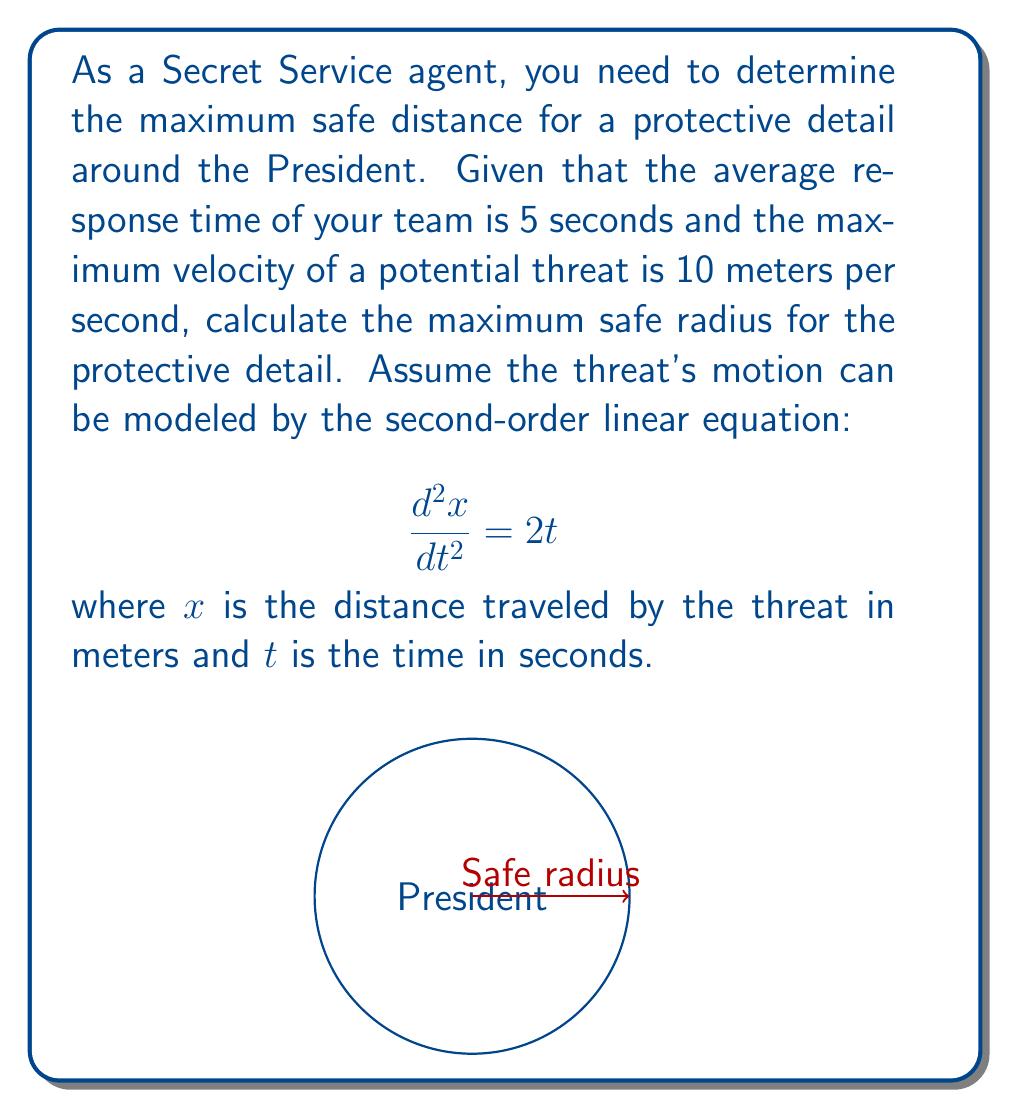Provide a solution to this math problem. To solve this problem, we need to follow these steps:

1) First, we integrate the given equation twice to find the position function:

   $$\frac{d^2x}{dt^2} = 2t$$
   $$\frac{dx}{dt} = t^2 + C_1$$
   $$x = \frac{1}{3}t^3 + C_1t + C_2$$

2) We're told the maximum velocity is 10 m/s, so we can use this to find $C_1$:

   $$\frac{dx}{dt} = t^2 + C_1 = 10$$
   $$5^2 + C_1 = 10$$
   $$C_1 = -15$$

3) Now our position function is:

   $$x = \frac{1}{3}t^3 - 15t + C_2$$

4) We can assume the threat starts at $x=0$ when $t=0$, so $C_2 = 0$

5) Now we can calculate the distance traveled in 5 seconds:

   $$x = \frac{1}{3}(5^3) - 15(5) = 20.8333 - 75 = -54.1667$$

6) The negative value indicates the threat is moving towards the President. The absolute value gives us the distance traveled:

   $$|x| = 54.1667 \text{ meters}$$

This is the maximum safe radius for the protective detail.
Answer: 54.17 meters 